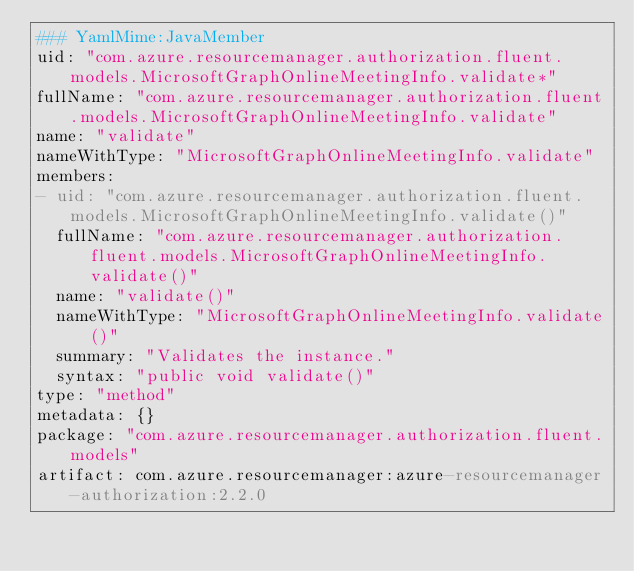Convert code to text. <code><loc_0><loc_0><loc_500><loc_500><_YAML_>### YamlMime:JavaMember
uid: "com.azure.resourcemanager.authorization.fluent.models.MicrosoftGraphOnlineMeetingInfo.validate*"
fullName: "com.azure.resourcemanager.authorization.fluent.models.MicrosoftGraphOnlineMeetingInfo.validate"
name: "validate"
nameWithType: "MicrosoftGraphOnlineMeetingInfo.validate"
members:
- uid: "com.azure.resourcemanager.authorization.fluent.models.MicrosoftGraphOnlineMeetingInfo.validate()"
  fullName: "com.azure.resourcemanager.authorization.fluent.models.MicrosoftGraphOnlineMeetingInfo.validate()"
  name: "validate()"
  nameWithType: "MicrosoftGraphOnlineMeetingInfo.validate()"
  summary: "Validates the instance."
  syntax: "public void validate()"
type: "method"
metadata: {}
package: "com.azure.resourcemanager.authorization.fluent.models"
artifact: com.azure.resourcemanager:azure-resourcemanager-authorization:2.2.0
</code> 